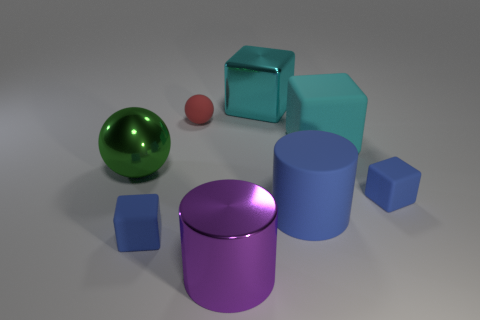Subtract all matte cubes. How many cubes are left? 1 Subtract all green cylinders. How many blue cubes are left? 2 Add 1 tiny purple matte cylinders. How many objects exist? 9 Subtract all red blocks. Subtract all cyan spheres. How many blocks are left? 4 Subtract all cylinders. How many objects are left? 6 Subtract all cyan metallic things. Subtract all blue things. How many objects are left? 4 Add 3 red things. How many red things are left? 4 Add 8 large green matte cylinders. How many large green matte cylinders exist? 8 Subtract 0 blue spheres. How many objects are left? 8 